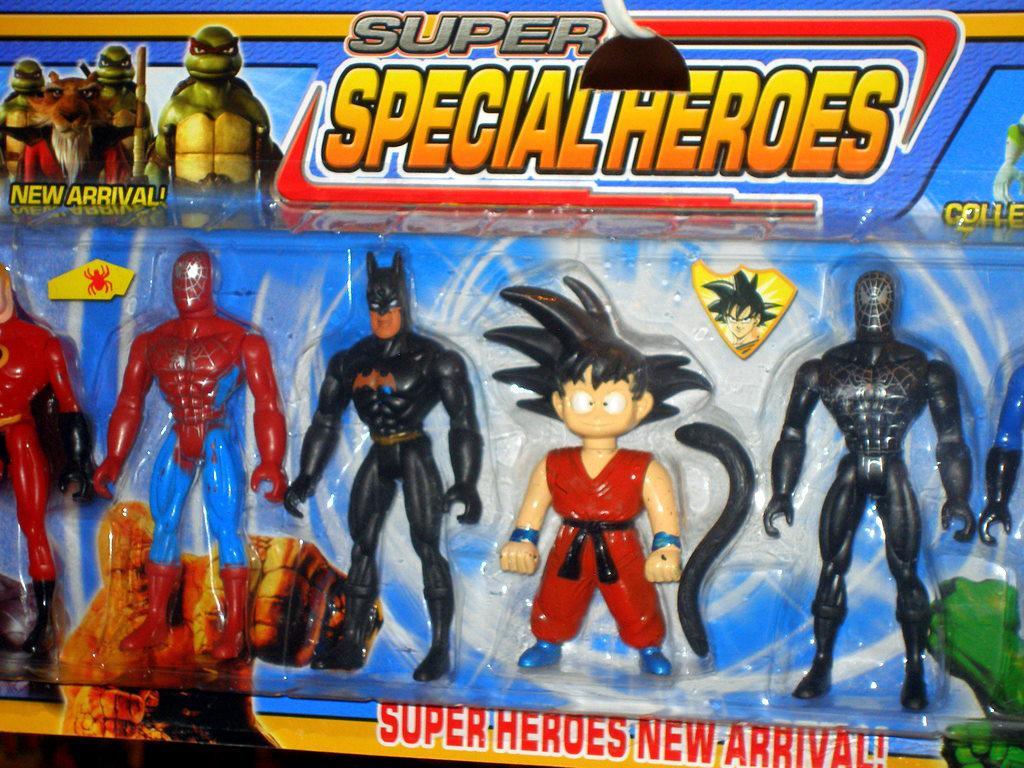What kind of heroes are in the package?
Give a very brief answer. Super special heroes. Is this a new arrival?
Give a very brief answer. Yes. 